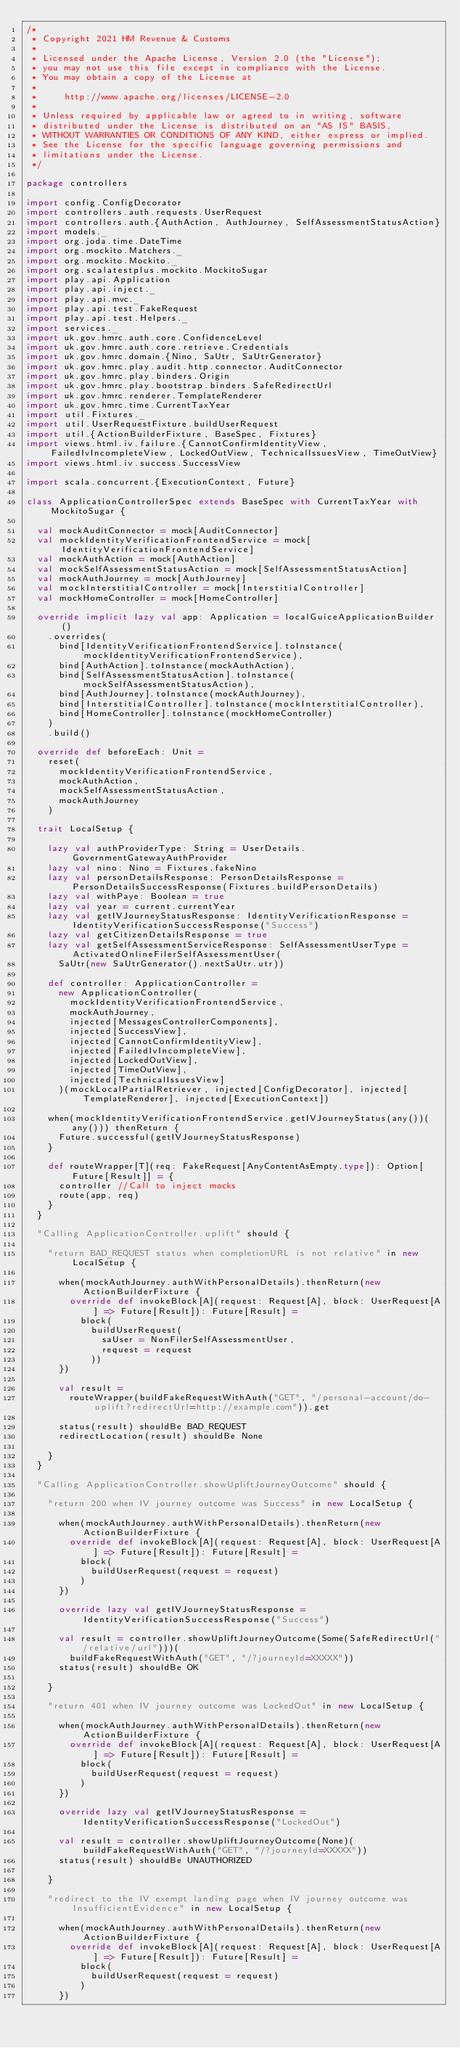<code> <loc_0><loc_0><loc_500><loc_500><_Scala_>/*
 * Copyright 2021 HM Revenue & Customs
 *
 * Licensed under the Apache License, Version 2.0 (the "License");
 * you may not use this file except in compliance with the License.
 * You may obtain a copy of the License at
 *
 *     http://www.apache.org/licenses/LICENSE-2.0
 *
 * Unless required by applicable law or agreed to in writing, software
 * distributed under the License is distributed on an "AS IS" BASIS,
 * WITHOUT WARRANTIES OR CONDITIONS OF ANY KIND, either express or implied.
 * See the License for the specific language governing permissions and
 * limitations under the License.
 */

package controllers

import config.ConfigDecorator
import controllers.auth.requests.UserRequest
import controllers.auth.{AuthAction, AuthJourney, SelfAssessmentStatusAction}
import models._
import org.joda.time.DateTime
import org.mockito.Matchers._
import org.mockito.Mockito._
import org.scalatestplus.mockito.MockitoSugar
import play.api.Application
import play.api.inject._
import play.api.mvc._
import play.api.test.FakeRequest
import play.api.test.Helpers._
import services._
import uk.gov.hmrc.auth.core.ConfidenceLevel
import uk.gov.hmrc.auth.core.retrieve.Credentials
import uk.gov.hmrc.domain.{Nino, SaUtr, SaUtrGenerator}
import uk.gov.hmrc.play.audit.http.connector.AuditConnector
import uk.gov.hmrc.play.binders.Origin
import uk.gov.hmrc.play.bootstrap.binders.SafeRedirectUrl
import uk.gov.hmrc.renderer.TemplateRenderer
import uk.gov.hmrc.time.CurrentTaxYear
import util.Fixtures._
import util.UserRequestFixture.buildUserRequest
import util.{ActionBuilderFixture, BaseSpec, Fixtures}
import views.html.iv.failure.{CannotConfirmIdentityView, FailedIvIncompleteView, LockedOutView, TechnicalIssuesView, TimeOutView}
import views.html.iv.success.SuccessView

import scala.concurrent.{ExecutionContext, Future}

class ApplicationControllerSpec extends BaseSpec with CurrentTaxYear with MockitoSugar {

  val mockAuditConnector = mock[AuditConnector]
  val mockIdentityVerificationFrontendService = mock[IdentityVerificationFrontendService]
  val mockAuthAction = mock[AuthAction]
  val mockSelfAssessmentStatusAction = mock[SelfAssessmentStatusAction]
  val mockAuthJourney = mock[AuthJourney]
  val mockInterstitialController = mock[InterstitialController]
  val mockHomeController = mock[HomeController]

  override implicit lazy val app: Application = localGuiceApplicationBuilder()
    .overrides(
      bind[IdentityVerificationFrontendService].toInstance(mockIdentityVerificationFrontendService),
      bind[AuthAction].toInstance(mockAuthAction),
      bind[SelfAssessmentStatusAction].toInstance(mockSelfAssessmentStatusAction),
      bind[AuthJourney].toInstance(mockAuthJourney),
      bind[InterstitialController].toInstance(mockInterstitialController),
      bind[HomeController].toInstance(mockHomeController)
    )
    .build()

  override def beforeEach: Unit =
    reset(
      mockIdentityVerificationFrontendService,
      mockAuthAction,
      mockSelfAssessmentStatusAction,
      mockAuthJourney
    )

  trait LocalSetup {

    lazy val authProviderType: String = UserDetails.GovernmentGatewayAuthProvider
    lazy val nino: Nino = Fixtures.fakeNino
    lazy val personDetailsResponse: PersonDetailsResponse = PersonDetailsSuccessResponse(Fixtures.buildPersonDetails)
    lazy val withPaye: Boolean = true
    lazy val year = current.currentYear
    lazy val getIVJourneyStatusResponse: IdentityVerificationResponse = IdentityVerificationSuccessResponse("Success")
    lazy val getCitizenDetailsResponse = true
    lazy val getSelfAssessmentServiceResponse: SelfAssessmentUserType = ActivatedOnlineFilerSelfAssessmentUser(
      SaUtr(new SaUtrGenerator().nextSaUtr.utr))

    def controller: ApplicationController =
      new ApplicationController(
        mockIdentityVerificationFrontendService,
        mockAuthJourney,
        injected[MessagesControllerComponents],
        injected[SuccessView],
        injected[CannotConfirmIdentityView],
        injected[FailedIvIncompleteView],
        injected[LockedOutView],
        injected[TimeOutView],
        injected[TechnicalIssuesView]
      )(mockLocalPartialRetriever, injected[ConfigDecorator], injected[TemplateRenderer], injected[ExecutionContext])

    when(mockIdentityVerificationFrontendService.getIVJourneyStatus(any())(any())) thenReturn {
      Future.successful(getIVJourneyStatusResponse)
    }

    def routeWrapper[T](req: FakeRequest[AnyContentAsEmpty.type]): Option[Future[Result]] = {
      controller //Call to inject mocks
      route(app, req)
    }
  }

  "Calling ApplicationController.uplift" should {

    "return BAD_REQUEST status when completionURL is not relative" in new LocalSetup {

      when(mockAuthJourney.authWithPersonalDetails).thenReturn(new ActionBuilderFixture {
        override def invokeBlock[A](request: Request[A], block: UserRequest[A] => Future[Result]): Future[Result] =
          block(
            buildUserRequest(
              saUser = NonFilerSelfAssessmentUser,
              request = request
            ))
      })

      val result =
        routeWrapper(buildFakeRequestWithAuth("GET", "/personal-account/do-uplift?redirectUrl=http://example.com")).get

      status(result) shouldBe BAD_REQUEST
      redirectLocation(result) shouldBe None

    }
  }

  "Calling ApplicationController.showUpliftJourneyOutcome" should {

    "return 200 when IV journey outcome was Success" in new LocalSetup {

      when(mockAuthJourney.authWithPersonalDetails).thenReturn(new ActionBuilderFixture {
        override def invokeBlock[A](request: Request[A], block: UserRequest[A] => Future[Result]): Future[Result] =
          block(
            buildUserRequest(request = request)
          )
      })

      override lazy val getIVJourneyStatusResponse = IdentityVerificationSuccessResponse("Success")

      val result = controller.showUpliftJourneyOutcome(Some(SafeRedirectUrl("/relative/url")))(
        buildFakeRequestWithAuth("GET", "/?journeyId=XXXXX"))
      status(result) shouldBe OK

    }

    "return 401 when IV journey outcome was LockedOut" in new LocalSetup {

      when(mockAuthJourney.authWithPersonalDetails).thenReturn(new ActionBuilderFixture {
        override def invokeBlock[A](request: Request[A], block: UserRequest[A] => Future[Result]): Future[Result] =
          block(
            buildUserRequest(request = request)
          )
      })

      override lazy val getIVJourneyStatusResponse = IdentityVerificationSuccessResponse("LockedOut")

      val result = controller.showUpliftJourneyOutcome(None)(buildFakeRequestWithAuth("GET", "/?journeyId=XXXXX"))
      status(result) shouldBe UNAUTHORIZED

    }

    "redirect to the IV exempt landing page when IV journey outcome was InsufficientEvidence" in new LocalSetup {

      when(mockAuthJourney.authWithPersonalDetails).thenReturn(new ActionBuilderFixture {
        override def invokeBlock[A](request: Request[A], block: UserRequest[A] => Future[Result]): Future[Result] =
          block(
            buildUserRequest(request = request)
          )
      })
</code> 